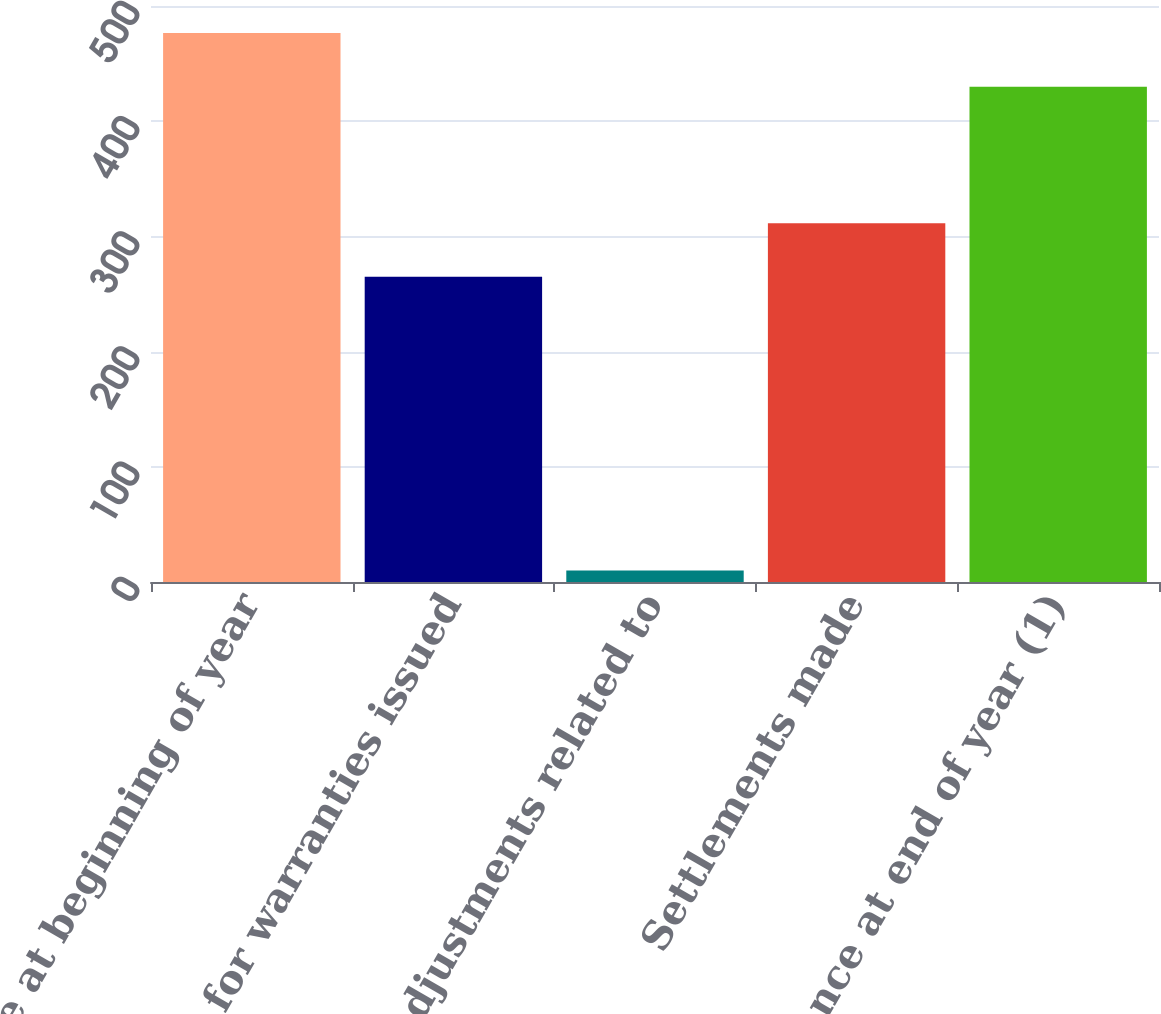<chart> <loc_0><loc_0><loc_500><loc_500><bar_chart><fcel>Balance at beginning of year<fcel>Accruals for warranties issued<fcel>Adjustments related to<fcel>Settlements made<fcel>Balance at end of year (1)<nl><fcel>476.5<fcel>265<fcel>10<fcel>311.5<fcel>430<nl></chart> 